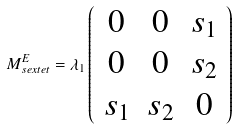Convert formula to latex. <formula><loc_0><loc_0><loc_500><loc_500>M _ { s e x t e t } ^ { E } = \lambda _ { 1 } \left ( \begin{array} { c c c } { 0 } & { 0 } & { { s _ { 1 } } } \\ { 0 } & { 0 } & { { s _ { 2 } } } \\ { { s _ { 1 } } } & { { s _ { 2 } } } & { 0 } \end{array} \right )</formula> 